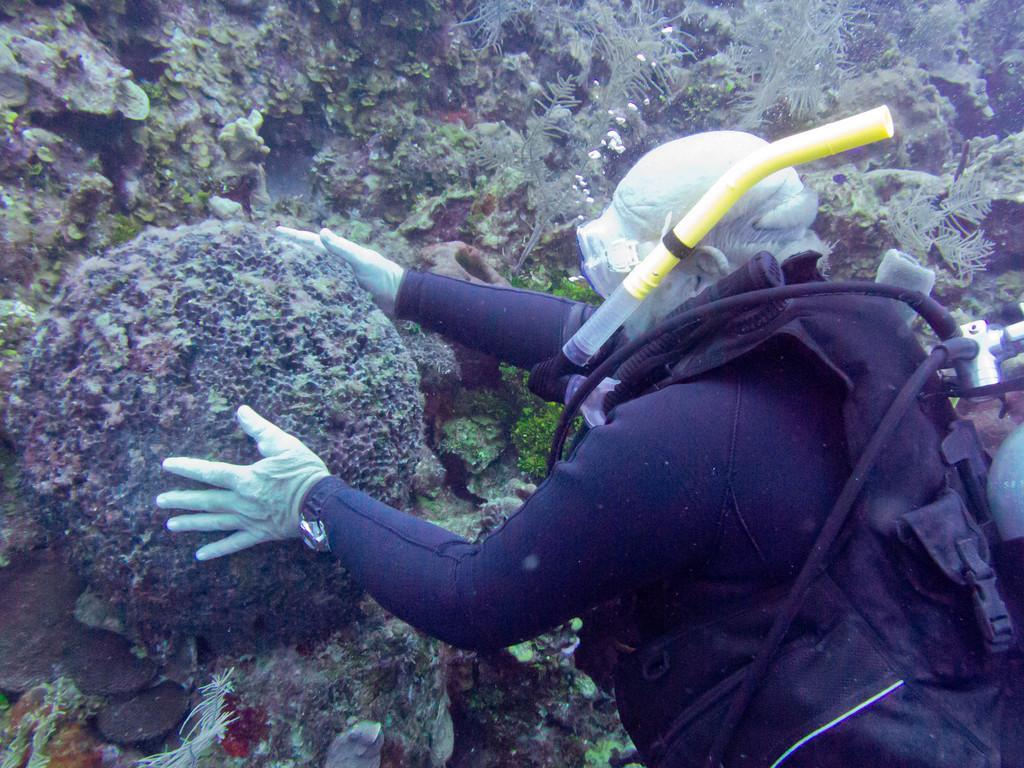Can you describe this image briefly? Here a person is swimming in the water, this person wore black color dress. 